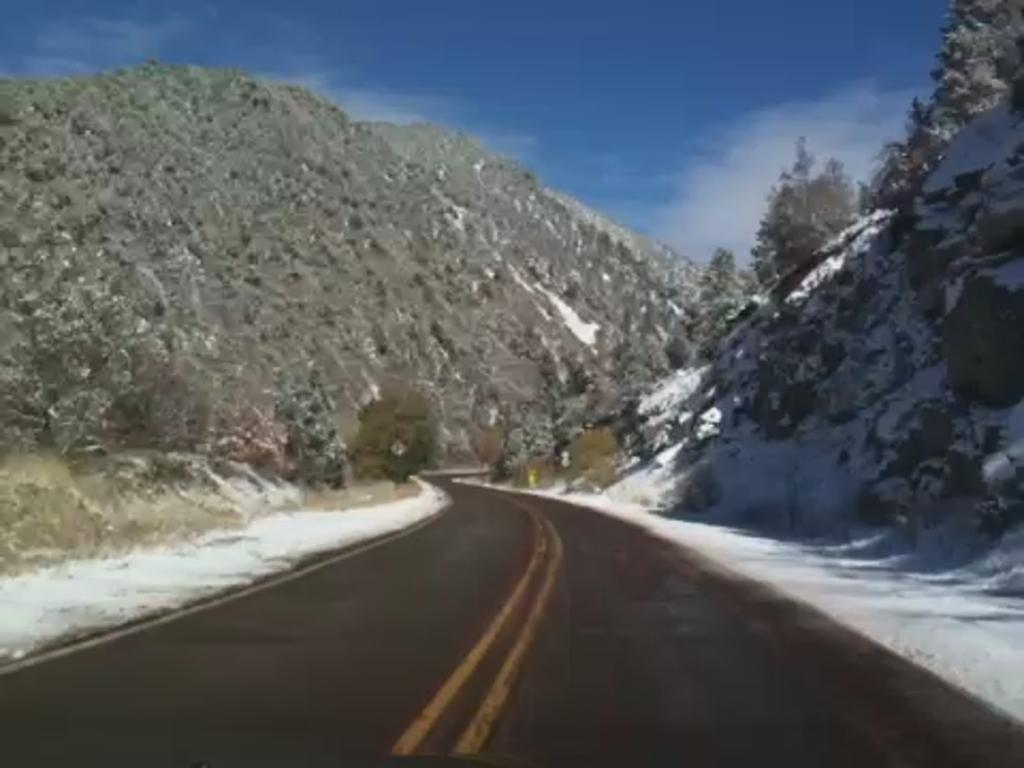What type of natural formation can be seen in the image? There are mountains in the image. What other natural elements are present in the image? There are trees in the image. What man-made object can be seen in the image? There is a board in the image. What is visible at the top of the image? The sky is visible at the top of the image. What is located at the bottom of the image? There is a road at the bottom of the image. Can you see a rabbit jumping over the mountains in the image? There is no rabbit or jumping action present in the image; it features mountains, trees, a board, the sky, and a road. What type of flag is flying over the trees in the image? There is no flag present in the image; it only features mountains, trees, a board, the sky, and a road. 